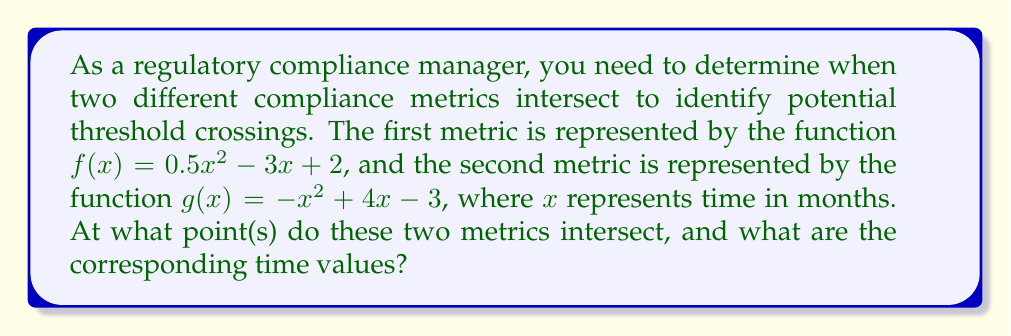Solve this math problem. To find the intersection points of the two polynomial functions, we need to solve the equation $f(x) = g(x)$:

$$0.5x^2 - 3x + 2 = -x^2 + 4x - 3$$

Let's solve this step-by-step:

1) First, move all terms to one side of the equation:
   $$0.5x^2 - 3x + 2 + x^2 - 4x + 3 = 0$$

2) Simplify by combining like terms:
   $$1.5x^2 - 7x + 5 = 0$$

3) This is a quadratic equation in the form $ax^2 + bx + c = 0$, where:
   $a = 1.5$, $b = -7$, and $c = 5$

4) We can solve this using the quadratic formula: $x = \frac{-b \pm \sqrt{b^2 - 4ac}}{2a}$

5) Substituting our values:
   $$x = \frac{7 \pm \sqrt{(-7)^2 - 4(1.5)(5)}}{2(1.5)}$$

6) Simplify:
   $$x = \frac{7 \pm \sqrt{49 - 30}}{3} = \frac{7 \pm \sqrt{19}}{3}$$

7) Calculate the two solutions:
   $$x_1 = \frac{7 + \sqrt{19}}{3} \approx 3.79$$
   $$x_2 = \frac{7 - \sqrt{19}}{3} \approx 0.88$$

These x-values represent the times (in months) when the two metrics intersect.
Answer: The two metrics intersect at approximately 0.88 months and 3.79 months. 